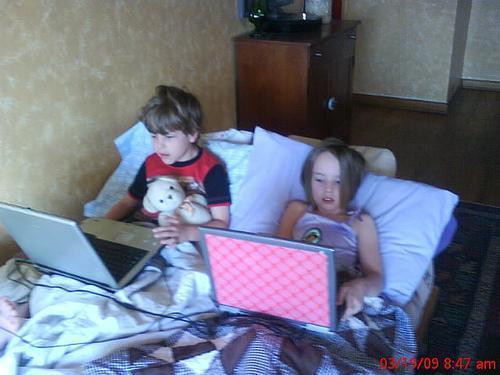How many laptops can you see?
Give a very brief answer. 2. How many people are in the photo?
Give a very brief answer. 2. How many zebras are facing left?
Give a very brief answer. 0. 